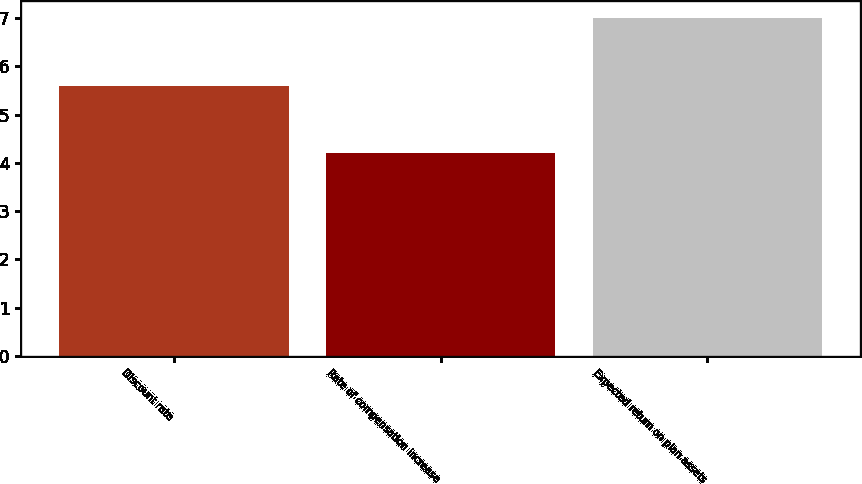Convert chart to OTSL. <chart><loc_0><loc_0><loc_500><loc_500><bar_chart><fcel>Discount rate<fcel>Rate of compensation increase<fcel>Expected return on plan assets<nl><fcel>5.6<fcel>4.2<fcel>7<nl></chart> 